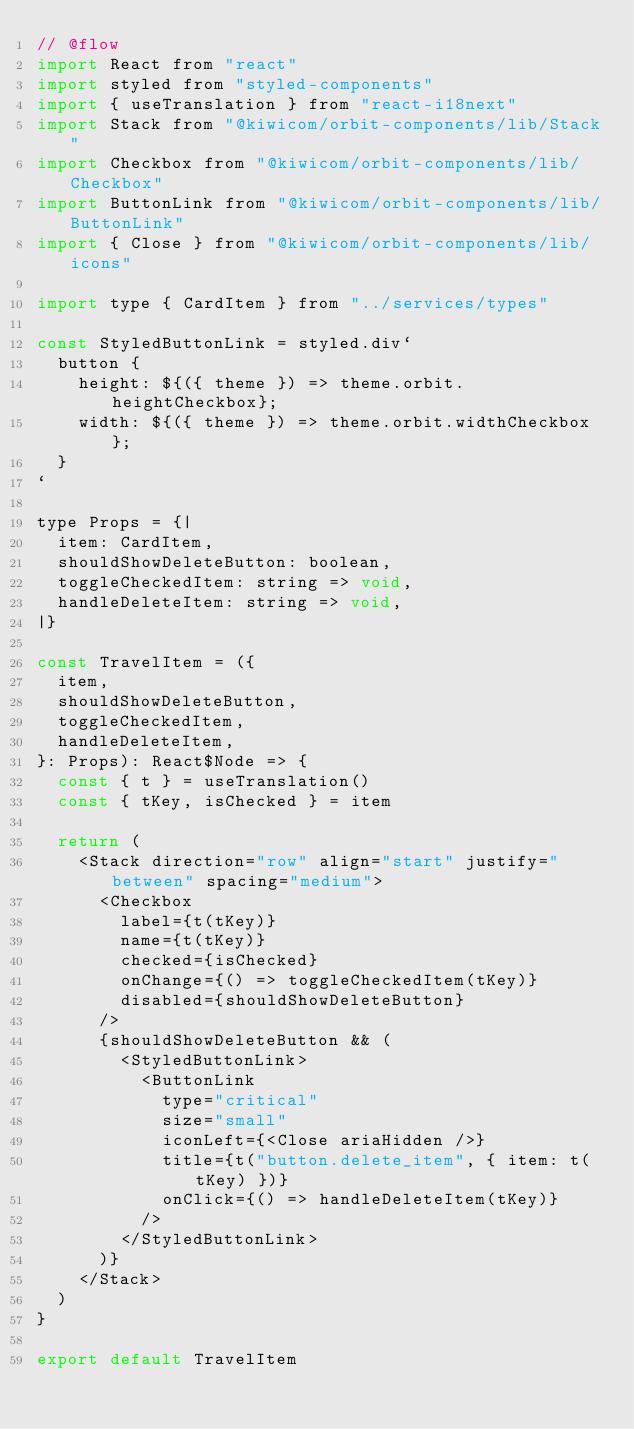<code> <loc_0><loc_0><loc_500><loc_500><_JavaScript_>// @flow
import React from "react"
import styled from "styled-components"
import { useTranslation } from "react-i18next"
import Stack from "@kiwicom/orbit-components/lib/Stack"
import Checkbox from "@kiwicom/orbit-components/lib/Checkbox"
import ButtonLink from "@kiwicom/orbit-components/lib/ButtonLink"
import { Close } from "@kiwicom/orbit-components/lib/icons"

import type { CardItem } from "../services/types"

const StyledButtonLink = styled.div`
  button {
    height: ${({ theme }) => theme.orbit.heightCheckbox};
    width: ${({ theme }) => theme.orbit.widthCheckbox};
  }
`

type Props = {|
  item: CardItem,
  shouldShowDeleteButton: boolean,
  toggleCheckedItem: string => void,
  handleDeleteItem: string => void,
|}

const TravelItem = ({
  item,
  shouldShowDeleteButton,
  toggleCheckedItem,
  handleDeleteItem,
}: Props): React$Node => {
  const { t } = useTranslation()
  const { tKey, isChecked } = item

  return (
    <Stack direction="row" align="start" justify="between" spacing="medium">
      <Checkbox
        label={t(tKey)}
        name={t(tKey)}
        checked={isChecked}
        onChange={() => toggleCheckedItem(tKey)}
        disabled={shouldShowDeleteButton}
      />
      {shouldShowDeleteButton && (
        <StyledButtonLink>
          <ButtonLink
            type="critical"
            size="small"
            iconLeft={<Close ariaHidden />}
            title={t("button.delete_item", { item: t(tKey) })}
            onClick={() => handleDeleteItem(tKey)}
          />
        </StyledButtonLink>
      )}
    </Stack>
  )
}

export default TravelItem
</code> 